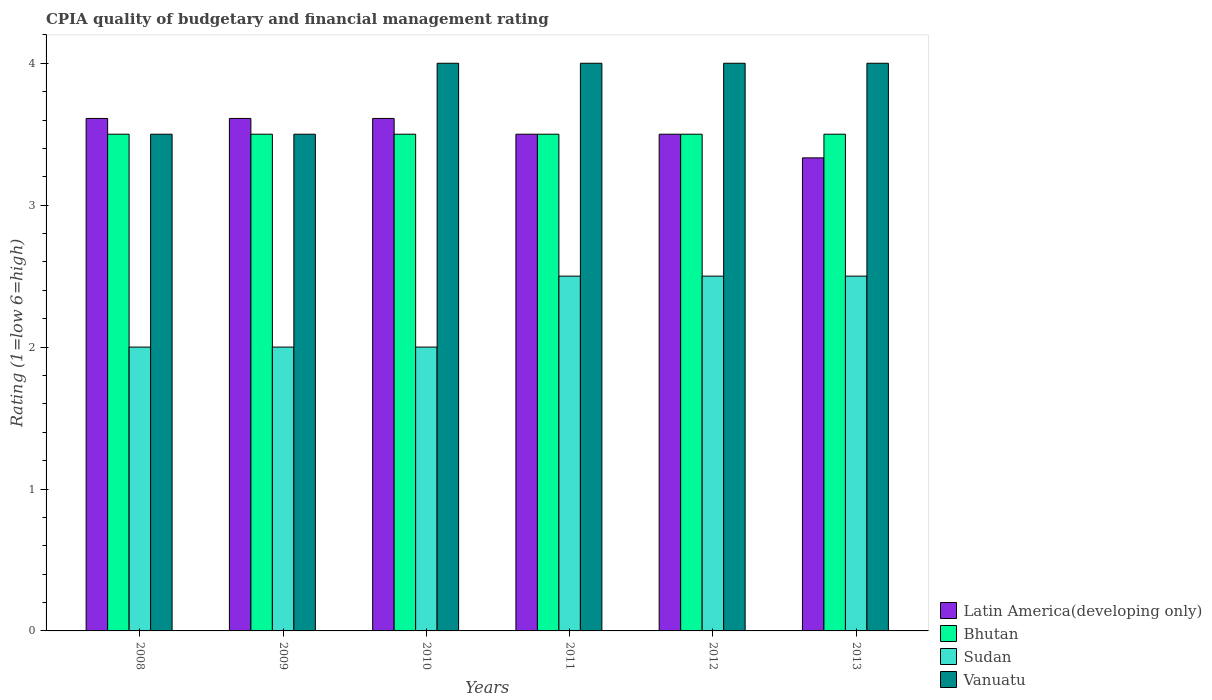How many different coloured bars are there?
Make the answer very short. 4. How many groups of bars are there?
Your response must be concise. 6. Are the number of bars per tick equal to the number of legend labels?
Offer a terse response. Yes. What is the CPIA rating in Vanuatu in 2008?
Ensure brevity in your answer.  3.5. Across all years, what is the maximum CPIA rating in Latin America(developing only)?
Offer a terse response. 3.61. Across all years, what is the minimum CPIA rating in Bhutan?
Make the answer very short. 3.5. In which year was the CPIA rating in Vanuatu maximum?
Make the answer very short. 2010. What is the total CPIA rating in Vanuatu in the graph?
Offer a terse response. 23. What is the difference between the CPIA rating in Vanuatu in 2009 and that in 2010?
Your answer should be very brief. -0.5. What is the difference between the CPIA rating in Bhutan in 2010 and the CPIA rating in Sudan in 2009?
Give a very brief answer. 1.5. What is the average CPIA rating in Latin America(developing only) per year?
Your answer should be very brief. 3.53. In the year 2009, what is the difference between the CPIA rating in Sudan and CPIA rating in Latin America(developing only)?
Give a very brief answer. -1.61. Is it the case that in every year, the sum of the CPIA rating in Latin America(developing only) and CPIA rating in Bhutan is greater than the sum of CPIA rating in Vanuatu and CPIA rating in Sudan?
Give a very brief answer. No. What does the 2nd bar from the left in 2009 represents?
Ensure brevity in your answer.  Bhutan. What does the 2nd bar from the right in 2012 represents?
Make the answer very short. Sudan. Is it the case that in every year, the sum of the CPIA rating in Vanuatu and CPIA rating in Latin America(developing only) is greater than the CPIA rating in Sudan?
Your answer should be compact. Yes. How many bars are there?
Your answer should be compact. 24. Are all the bars in the graph horizontal?
Ensure brevity in your answer.  No. Are the values on the major ticks of Y-axis written in scientific E-notation?
Your response must be concise. No. Does the graph contain any zero values?
Provide a short and direct response. No. Does the graph contain grids?
Provide a short and direct response. No. Where does the legend appear in the graph?
Provide a short and direct response. Bottom right. What is the title of the graph?
Give a very brief answer. CPIA quality of budgetary and financial management rating. What is the label or title of the Y-axis?
Ensure brevity in your answer.  Rating (1=low 6=high). What is the Rating (1=low 6=high) in Latin America(developing only) in 2008?
Give a very brief answer. 3.61. What is the Rating (1=low 6=high) in Bhutan in 2008?
Give a very brief answer. 3.5. What is the Rating (1=low 6=high) of Vanuatu in 2008?
Your answer should be very brief. 3.5. What is the Rating (1=low 6=high) in Latin America(developing only) in 2009?
Provide a succinct answer. 3.61. What is the Rating (1=low 6=high) in Vanuatu in 2009?
Provide a succinct answer. 3.5. What is the Rating (1=low 6=high) in Latin America(developing only) in 2010?
Your answer should be very brief. 3.61. What is the Rating (1=low 6=high) in Sudan in 2010?
Keep it short and to the point. 2. What is the Rating (1=low 6=high) in Vanuatu in 2010?
Give a very brief answer. 4. What is the Rating (1=low 6=high) of Latin America(developing only) in 2011?
Provide a succinct answer. 3.5. What is the Rating (1=low 6=high) in Vanuatu in 2011?
Provide a succinct answer. 4. What is the Rating (1=low 6=high) of Latin America(developing only) in 2012?
Offer a very short reply. 3.5. What is the Rating (1=low 6=high) of Bhutan in 2012?
Your response must be concise. 3.5. What is the Rating (1=low 6=high) in Sudan in 2012?
Keep it short and to the point. 2.5. What is the Rating (1=low 6=high) in Vanuatu in 2012?
Your answer should be compact. 4. What is the Rating (1=low 6=high) in Latin America(developing only) in 2013?
Make the answer very short. 3.33. What is the Rating (1=low 6=high) of Sudan in 2013?
Offer a very short reply. 2.5. What is the Rating (1=low 6=high) of Vanuatu in 2013?
Offer a very short reply. 4. Across all years, what is the maximum Rating (1=low 6=high) in Latin America(developing only)?
Give a very brief answer. 3.61. Across all years, what is the maximum Rating (1=low 6=high) in Vanuatu?
Your answer should be very brief. 4. Across all years, what is the minimum Rating (1=low 6=high) of Latin America(developing only)?
Ensure brevity in your answer.  3.33. Across all years, what is the minimum Rating (1=low 6=high) in Sudan?
Make the answer very short. 2. Across all years, what is the minimum Rating (1=low 6=high) in Vanuatu?
Make the answer very short. 3.5. What is the total Rating (1=low 6=high) of Latin America(developing only) in the graph?
Give a very brief answer. 21.17. What is the total Rating (1=low 6=high) in Bhutan in the graph?
Give a very brief answer. 21. What is the difference between the Rating (1=low 6=high) of Latin America(developing only) in 2008 and that in 2010?
Give a very brief answer. 0. What is the difference between the Rating (1=low 6=high) of Latin America(developing only) in 2008 and that in 2011?
Provide a short and direct response. 0.11. What is the difference between the Rating (1=low 6=high) of Bhutan in 2008 and that in 2012?
Keep it short and to the point. 0. What is the difference between the Rating (1=low 6=high) of Sudan in 2008 and that in 2012?
Provide a succinct answer. -0.5. What is the difference between the Rating (1=low 6=high) in Vanuatu in 2008 and that in 2012?
Provide a short and direct response. -0.5. What is the difference between the Rating (1=low 6=high) in Latin America(developing only) in 2008 and that in 2013?
Ensure brevity in your answer.  0.28. What is the difference between the Rating (1=low 6=high) in Bhutan in 2008 and that in 2013?
Your answer should be very brief. 0. What is the difference between the Rating (1=low 6=high) in Sudan in 2008 and that in 2013?
Offer a very short reply. -0.5. What is the difference between the Rating (1=low 6=high) of Vanuatu in 2008 and that in 2013?
Offer a very short reply. -0.5. What is the difference between the Rating (1=low 6=high) of Bhutan in 2009 and that in 2010?
Your answer should be very brief. 0. What is the difference between the Rating (1=low 6=high) in Vanuatu in 2009 and that in 2010?
Offer a terse response. -0.5. What is the difference between the Rating (1=low 6=high) of Sudan in 2009 and that in 2011?
Your response must be concise. -0.5. What is the difference between the Rating (1=low 6=high) of Vanuatu in 2009 and that in 2011?
Give a very brief answer. -0.5. What is the difference between the Rating (1=low 6=high) of Latin America(developing only) in 2009 and that in 2013?
Ensure brevity in your answer.  0.28. What is the difference between the Rating (1=low 6=high) of Sudan in 2009 and that in 2013?
Make the answer very short. -0.5. What is the difference between the Rating (1=low 6=high) of Vanuatu in 2009 and that in 2013?
Ensure brevity in your answer.  -0.5. What is the difference between the Rating (1=low 6=high) of Vanuatu in 2010 and that in 2011?
Make the answer very short. 0. What is the difference between the Rating (1=low 6=high) in Latin America(developing only) in 2010 and that in 2012?
Offer a very short reply. 0.11. What is the difference between the Rating (1=low 6=high) of Latin America(developing only) in 2010 and that in 2013?
Provide a succinct answer. 0.28. What is the difference between the Rating (1=low 6=high) in Sudan in 2010 and that in 2013?
Provide a short and direct response. -0.5. What is the difference between the Rating (1=low 6=high) of Sudan in 2011 and that in 2012?
Your answer should be very brief. 0. What is the difference between the Rating (1=low 6=high) of Bhutan in 2011 and that in 2013?
Provide a short and direct response. 0. What is the difference between the Rating (1=low 6=high) of Vanuatu in 2011 and that in 2013?
Your answer should be very brief. 0. What is the difference between the Rating (1=low 6=high) of Latin America(developing only) in 2012 and that in 2013?
Your answer should be very brief. 0.17. What is the difference between the Rating (1=low 6=high) in Sudan in 2012 and that in 2013?
Your answer should be very brief. 0. What is the difference between the Rating (1=low 6=high) in Vanuatu in 2012 and that in 2013?
Offer a very short reply. 0. What is the difference between the Rating (1=low 6=high) in Latin America(developing only) in 2008 and the Rating (1=low 6=high) in Bhutan in 2009?
Provide a short and direct response. 0.11. What is the difference between the Rating (1=low 6=high) of Latin America(developing only) in 2008 and the Rating (1=low 6=high) of Sudan in 2009?
Ensure brevity in your answer.  1.61. What is the difference between the Rating (1=low 6=high) of Latin America(developing only) in 2008 and the Rating (1=low 6=high) of Vanuatu in 2009?
Keep it short and to the point. 0.11. What is the difference between the Rating (1=low 6=high) in Bhutan in 2008 and the Rating (1=low 6=high) in Vanuatu in 2009?
Ensure brevity in your answer.  0. What is the difference between the Rating (1=low 6=high) in Latin America(developing only) in 2008 and the Rating (1=low 6=high) in Bhutan in 2010?
Give a very brief answer. 0.11. What is the difference between the Rating (1=low 6=high) of Latin America(developing only) in 2008 and the Rating (1=low 6=high) of Sudan in 2010?
Make the answer very short. 1.61. What is the difference between the Rating (1=low 6=high) in Latin America(developing only) in 2008 and the Rating (1=low 6=high) in Vanuatu in 2010?
Your answer should be very brief. -0.39. What is the difference between the Rating (1=low 6=high) in Bhutan in 2008 and the Rating (1=low 6=high) in Vanuatu in 2010?
Provide a succinct answer. -0.5. What is the difference between the Rating (1=low 6=high) of Latin America(developing only) in 2008 and the Rating (1=low 6=high) of Bhutan in 2011?
Offer a very short reply. 0.11. What is the difference between the Rating (1=low 6=high) of Latin America(developing only) in 2008 and the Rating (1=low 6=high) of Sudan in 2011?
Provide a succinct answer. 1.11. What is the difference between the Rating (1=low 6=high) in Latin America(developing only) in 2008 and the Rating (1=low 6=high) in Vanuatu in 2011?
Your response must be concise. -0.39. What is the difference between the Rating (1=low 6=high) of Bhutan in 2008 and the Rating (1=low 6=high) of Sudan in 2011?
Offer a terse response. 1. What is the difference between the Rating (1=low 6=high) in Bhutan in 2008 and the Rating (1=low 6=high) in Vanuatu in 2011?
Keep it short and to the point. -0.5. What is the difference between the Rating (1=low 6=high) of Latin America(developing only) in 2008 and the Rating (1=low 6=high) of Sudan in 2012?
Your answer should be very brief. 1.11. What is the difference between the Rating (1=low 6=high) in Latin America(developing only) in 2008 and the Rating (1=low 6=high) in Vanuatu in 2012?
Provide a succinct answer. -0.39. What is the difference between the Rating (1=low 6=high) of Bhutan in 2008 and the Rating (1=low 6=high) of Sudan in 2012?
Offer a terse response. 1. What is the difference between the Rating (1=low 6=high) in Latin America(developing only) in 2008 and the Rating (1=low 6=high) in Sudan in 2013?
Your response must be concise. 1.11. What is the difference between the Rating (1=low 6=high) of Latin America(developing only) in 2008 and the Rating (1=low 6=high) of Vanuatu in 2013?
Keep it short and to the point. -0.39. What is the difference between the Rating (1=low 6=high) in Sudan in 2008 and the Rating (1=low 6=high) in Vanuatu in 2013?
Provide a succinct answer. -2. What is the difference between the Rating (1=low 6=high) in Latin America(developing only) in 2009 and the Rating (1=low 6=high) in Sudan in 2010?
Make the answer very short. 1.61. What is the difference between the Rating (1=low 6=high) in Latin America(developing only) in 2009 and the Rating (1=low 6=high) in Vanuatu in 2010?
Provide a short and direct response. -0.39. What is the difference between the Rating (1=low 6=high) of Bhutan in 2009 and the Rating (1=low 6=high) of Vanuatu in 2010?
Make the answer very short. -0.5. What is the difference between the Rating (1=low 6=high) of Latin America(developing only) in 2009 and the Rating (1=low 6=high) of Vanuatu in 2011?
Your answer should be compact. -0.39. What is the difference between the Rating (1=low 6=high) of Bhutan in 2009 and the Rating (1=low 6=high) of Sudan in 2011?
Your answer should be very brief. 1. What is the difference between the Rating (1=low 6=high) of Sudan in 2009 and the Rating (1=low 6=high) of Vanuatu in 2011?
Provide a succinct answer. -2. What is the difference between the Rating (1=low 6=high) in Latin America(developing only) in 2009 and the Rating (1=low 6=high) in Vanuatu in 2012?
Give a very brief answer. -0.39. What is the difference between the Rating (1=low 6=high) in Bhutan in 2009 and the Rating (1=low 6=high) in Vanuatu in 2012?
Provide a short and direct response. -0.5. What is the difference between the Rating (1=low 6=high) in Sudan in 2009 and the Rating (1=low 6=high) in Vanuatu in 2012?
Offer a very short reply. -2. What is the difference between the Rating (1=low 6=high) in Latin America(developing only) in 2009 and the Rating (1=low 6=high) in Vanuatu in 2013?
Provide a short and direct response. -0.39. What is the difference between the Rating (1=low 6=high) of Bhutan in 2009 and the Rating (1=low 6=high) of Sudan in 2013?
Offer a terse response. 1. What is the difference between the Rating (1=low 6=high) of Sudan in 2009 and the Rating (1=low 6=high) of Vanuatu in 2013?
Provide a succinct answer. -2. What is the difference between the Rating (1=low 6=high) in Latin America(developing only) in 2010 and the Rating (1=low 6=high) in Bhutan in 2011?
Offer a very short reply. 0.11. What is the difference between the Rating (1=low 6=high) of Latin America(developing only) in 2010 and the Rating (1=low 6=high) of Vanuatu in 2011?
Offer a very short reply. -0.39. What is the difference between the Rating (1=low 6=high) of Latin America(developing only) in 2010 and the Rating (1=low 6=high) of Bhutan in 2012?
Your answer should be compact. 0.11. What is the difference between the Rating (1=low 6=high) in Latin America(developing only) in 2010 and the Rating (1=low 6=high) in Sudan in 2012?
Your answer should be very brief. 1.11. What is the difference between the Rating (1=low 6=high) of Latin America(developing only) in 2010 and the Rating (1=low 6=high) of Vanuatu in 2012?
Keep it short and to the point. -0.39. What is the difference between the Rating (1=low 6=high) in Bhutan in 2010 and the Rating (1=low 6=high) in Sudan in 2012?
Ensure brevity in your answer.  1. What is the difference between the Rating (1=low 6=high) of Bhutan in 2010 and the Rating (1=low 6=high) of Vanuatu in 2012?
Provide a short and direct response. -0.5. What is the difference between the Rating (1=low 6=high) in Latin America(developing only) in 2010 and the Rating (1=low 6=high) in Vanuatu in 2013?
Provide a succinct answer. -0.39. What is the difference between the Rating (1=low 6=high) of Bhutan in 2010 and the Rating (1=low 6=high) of Sudan in 2013?
Your response must be concise. 1. What is the difference between the Rating (1=low 6=high) of Bhutan in 2010 and the Rating (1=low 6=high) of Vanuatu in 2013?
Provide a succinct answer. -0.5. What is the difference between the Rating (1=low 6=high) in Sudan in 2010 and the Rating (1=low 6=high) in Vanuatu in 2013?
Offer a terse response. -2. What is the difference between the Rating (1=low 6=high) in Latin America(developing only) in 2011 and the Rating (1=low 6=high) in Vanuatu in 2012?
Provide a succinct answer. -0.5. What is the difference between the Rating (1=low 6=high) of Sudan in 2011 and the Rating (1=low 6=high) of Vanuatu in 2012?
Offer a terse response. -1.5. What is the difference between the Rating (1=low 6=high) in Latin America(developing only) in 2011 and the Rating (1=low 6=high) in Bhutan in 2013?
Give a very brief answer. 0. What is the difference between the Rating (1=low 6=high) of Bhutan in 2011 and the Rating (1=low 6=high) of Vanuatu in 2013?
Your response must be concise. -0.5. What is the difference between the Rating (1=low 6=high) of Latin America(developing only) in 2012 and the Rating (1=low 6=high) of Sudan in 2013?
Offer a terse response. 1. What is the difference between the Rating (1=low 6=high) in Bhutan in 2012 and the Rating (1=low 6=high) in Sudan in 2013?
Give a very brief answer. 1. What is the average Rating (1=low 6=high) of Latin America(developing only) per year?
Offer a very short reply. 3.53. What is the average Rating (1=low 6=high) in Sudan per year?
Offer a terse response. 2.25. What is the average Rating (1=low 6=high) of Vanuatu per year?
Offer a terse response. 3.83. In the year 2008, what is the difference between the Rating (1=low 6=high) of Latin America(developing only) and Rating (1=low 6=high) of Bhutan?
Ensure brevity in your answer.  0.11. In the year 2008, what is the difference between the Rating (1=low 6=high) of Latin America(developing only) and Rating (1=low 6=high) of Sudan?
Offer a very short reply. 1.61. In the year 2008, what is the difference between the Rating (1=low 6=high) in Sudan and Rating (1=low 6=high) in Vanuatu?
Give a very brief answer. -1.5. In the year 2009, what is the difference between the Rating (1=low 6=high) in Latin America(developing only) and Rating (1=low 6=high) in Sudan?
Give a very brief answer. 1.61. In the year 2009, what is the difference between the Rating (1=low 6=high) in Bhutan and Rating (1=low 6=high) in Sudan?
Offer a very short reply. 1.5. In the year 2009, what is the difference between the Rating (1=low 6=high) in Bhutan and Rating (1=low 6=high) in Vanuatu?
Keep it short and to the point. 0. In the year 2010, what is the difference between the Rating (1=low 6=high) of Latin America(developing only) and Rating (1=low 6=high) of Sudan?
Offer a very short reply. 1.61. In the year 2010, what is the difference between the Rating (1=low 6=high) of Latin America(developing only) and Rating (1=low 6=high) of Vanuatu?
Provide a short and direct response. -0.39. In the year 2010, what is the difference between the Rating (1=low 6=high) of Bhutan and Rating (1=low 6=high) of Sudan?
Offer a terse response. 1.5. In the year 2011, what is the difference between the Rating (1=low 6=high) in Latin America(developing only) and Rating (1=low 6=high) in Bhutan?
Your answer should be very brief. 0. In the year 2011, what is the difference between the Rating (1=low 6=high) of Latin America(developing only) and Rating (1=low 6=high) of Vanuatu?
Your answer should be compact. -0.5. In the year 2011, what is the difference between the Rating (1=low 6=high) of Bhutan and Rating (1=low 6=high) of Sudan?
Ensure brevity in your answer.  1. In the year 2011, what is the difference between the Rating (1=low 6=high) in Sudan and Rating (1=low 6=high) in Vanuatu?
Offer a very short reply. -1.5. In the year 2012, what is the difference between the Rating (1=low 6=high) of Latin America(developing only) and Rating (1=low 6=high) of Vanuatu?
Make the answer very short. -0.5. In the year 2012, what is the difference between the Rating (1=low 6=high) of Bhutan and Rating (1=low 6=high) of Sudan?
Provide a succinct answer. 1. In the year 2012, what is the difference between the Rating (1=low 6=high) in Bhutan and Rating (1=low 6=high) in Vanuatu?
Ensure brevity in your answer.  -0.5. In the year 2013, what is the difference between the Rating (1=low 6=high) in Latin America(developing only) and Rating (1=low 6=high) in Bhutan?
Ensure brevity in your answer.  -0.17. In the year 2013, what is the difference between the Rating (1=low 6=high) of Latin America(developing only) and Rating (1=low 6=high) of Sudan?
Your answer should be compact. 0.83. In the year 2013, what is the difference between the Rating (1=low 6=high) in Latin America(developing only) and Rating (1=low 6=high) in Vanuatu?
Make the answer very short. -0.67. What is the ratio of the Rating (1=low 6=high) in Vanuatu in 2008 to that in 2009?
Offer a very short reply. 1. What is the ratio of the Rating (1=low 6=high) of Sudan in 2008 to that in 2010?
Provide a short and direct response. 1. What is the ratio of the Rating (1=low 6=high) of Latin America(developing only) in 2008 to that in 2011?
Ensure brevity in your answer.  1.03. What is the ratio of the Rating (1=low 6=high) in Vanuatu in 2008 to that in 2011?
Ensure brevity in your answer.  0.88. What is the ratio of the Rating (1=low 6=high) of Latin America(developing only) in 2008 to that in 2012?
Keep it short and to the point. 1.03. What is the ratio of the Rating (1=low 6=high) in Bhutan in 2008 to that in 2012?
Provide a succinct answer. 1. What is the ratio of the Rating (1=low 6=high) of Sudan in 2008 to that in 2012?
Offer a very short reply. 0.8. What is the ratio of the Rating (1=low 6=high) of Vanuatu in 2008 to that in 2012?
Give a very brief answer. 0.88. What is the ratio of the Rating (1=low 6=high) in Latin America(developing only) in 2008 to that in 2013?
Provide a short and direct response. 1.08. What is the ratio of the Rating (1=low 6=high) of Bhutan in 2009 to that in 2010?
Provide a short and direct response. 1. What is the ratio of the Rating (1=low 6=high) in Vanuatu in 2009 to that in 2010?
Keep it short and to the point. 0.88. What is the ratio of the Rating (1=low 6=high) in Latin America(developing only) in 2009 to that in 2011?
Your answer should be compact. 1.03. What is the ratio of the Rating (1=low 6=high) of Vanuatu in 2009 to that in 2011?
Keep it short and to the point. 0.88. What is the ratio of the Rating (1=low 6=high) in Latin America(developing only) in 2009 to that in 2012?
Offer a terse response. 1.03. What is the ratio of the Rating (1=low 6=high) of Bhutan in 2009 to that in 2013?
Your response must be concise. 1. What is the ratio of the Rating (1=low 6=high) in Latin America(developing only) in 2010 to that in 2011?
Offer a very short reply. 1.03. What is the ratio of the Rating (1=low 6=high) in Sudan in 2010 to that in 2011?
Provide a succinct answer. 0.8. What is the ratio of the Rating (1=low 6=high) in Vanuatu in 2010 to that in 2011?
Provide a succinct answer. 1. What is the ratio of the Rating (1=low 6=high) in Latin America(developing only) in 2010 to that in 2012?
Keep it short and to the point. 1.03. What is the ratio of the Rating (1=low 6=high) of Sudan in 2010 to that in 2012?
Provide a short and direct response. 0.8. What is the ratio of the Rating (1=low 6=high) in Vanuatu in 2010 to that in 2012?
Provide a succinct answer. 1. What is the ratio of the Rating (1=low 6=high) in Latin America(developing only) in 2010 to that in 2013?
Offer a terse response. 1.08. What is the ratio of the Rating (1=low 6=high) in Bhutan in 2010 to that in 2013?
Make the answer very short. 1. What is the ratio of the Rating (1=low 6=high) in Sudan in 2010 to that in 2013?
Make the answer very short. 0.8. What is the ratio of the Rating (1=low 6=high) in Vanuatu in 2010 to that in 2013?
Offer a very short reply. 1. What is the ratio of the Rating (1=low 6=high) in Bhutan in 2011 to that in 2012?
Ensure brevity in your answer.  1. What is the ratio of the Rating (1=low 6=high) in Sudan in 2011 to that in 2012?
Ensure brevity in your answer.  1. What is the ratio of the Rating (1=low 6=high) of Vanuatu in 2011 to that in 2012?
Your answer should be compact. 1. What is the ratio of the Rating (1=low 6=high) of Bhutan in 2011 to that in 2013?
Your answer should be compact. 1. What is the ratio of the Rating (1=low 6=high) of Sudan in 2011 to that in 2013?
Provide a succinct answer. 1. What is the ratio of the Rating (1=low 6=high) in Latin America(developing only) in 2012 to that in 2013?
Provide a short and direct response. 1.05. What is the ratio of the Rating (1=low 6=high) of Sudan in 2012 to that in 2013?
Offer a terse response. 1. What is the ratio of the Rating (1=low 6=high) in Vanuatu in 2012 to that in 2013?
Offer a terse response. 1. What is the difference between the highest and the second highest Rating (1=low 6=high) of Latin America(developing only)?
Give a very brief answer. 0. What is the difference between the highest and the second highest Rating (1=low 6=high) in Sudan?
Give a very brief answer. 0. What is the difference between the highest and the lowest Rating (1=low 6=high) of Latin America(developing only)?
Your answer should be very brief. 0.28. 